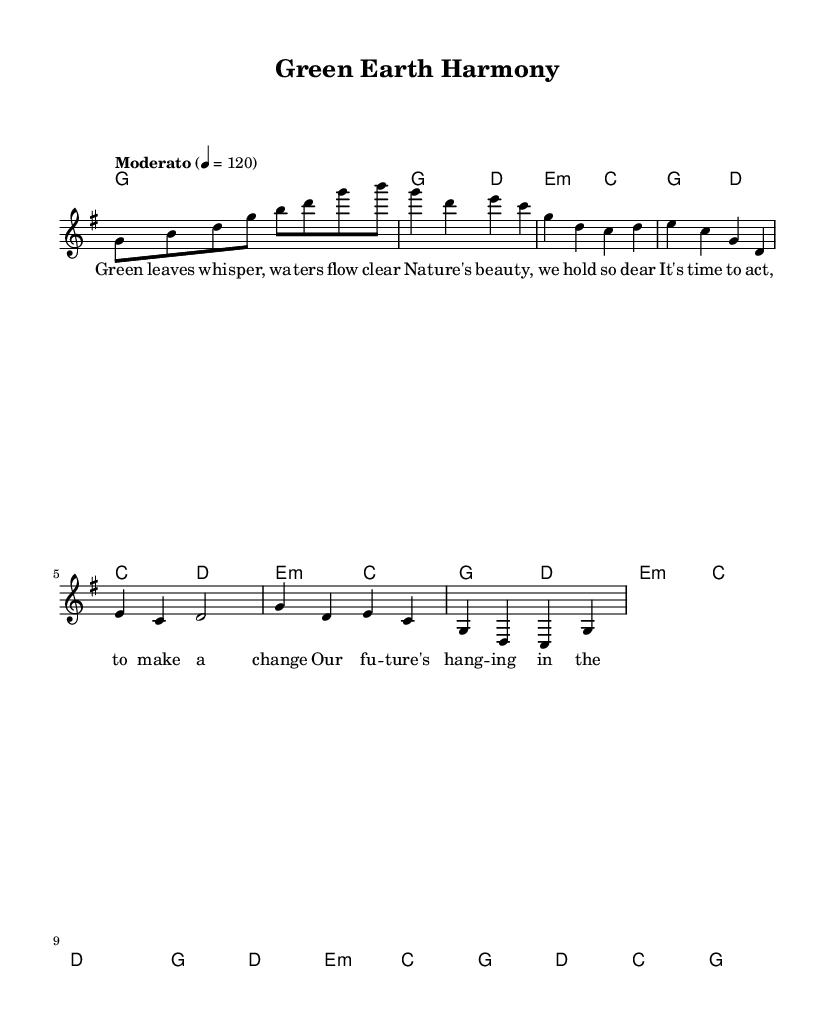What is the key signature of this music? The key signature is G major, which has one sharp (F#). This is indicated in the global section and is consistent throughout the piece.
Answer: G major What is the time signature of this music? The time signature is 4/4, which means there are four beats in each measure and the quarter note gets one beat. This is stated in the global section.
Answer: 4/4 What is the tempo of this music? The tempo is Moderato, marked at 120 beats per minute. This tempo indication is given in the global section of the music.
Answer: Moderato How many measures are there in the verse? There are four measures in the verse, which is composed of two groups of two measures each and can be identified in the melody and harmonies sections.
Answer: Four In the chorus, which word is repeated? The word "our" is repeated in the chorus lyrics, emphasizing the collective responsibility to protect the Earth. This can be observed in the repeated line "it's our only home".
Answer: Our What kind of theme does the song focus on? The theme focuses on environmental conservation and protection of nature. This is evident from the lyrics that speak about nature’s beauty and the call to action to protect the Earth.
Answer: Environmental conservation What is the structure of the song? The structure includes an Intro, Verse, Pre-Chorus, and Chorus, which is a common format in K-Pop songs. This can be inferred from the order of the sections provided in the music.
Answer: Intro, Verse, Pre-Chorus, Chorus 